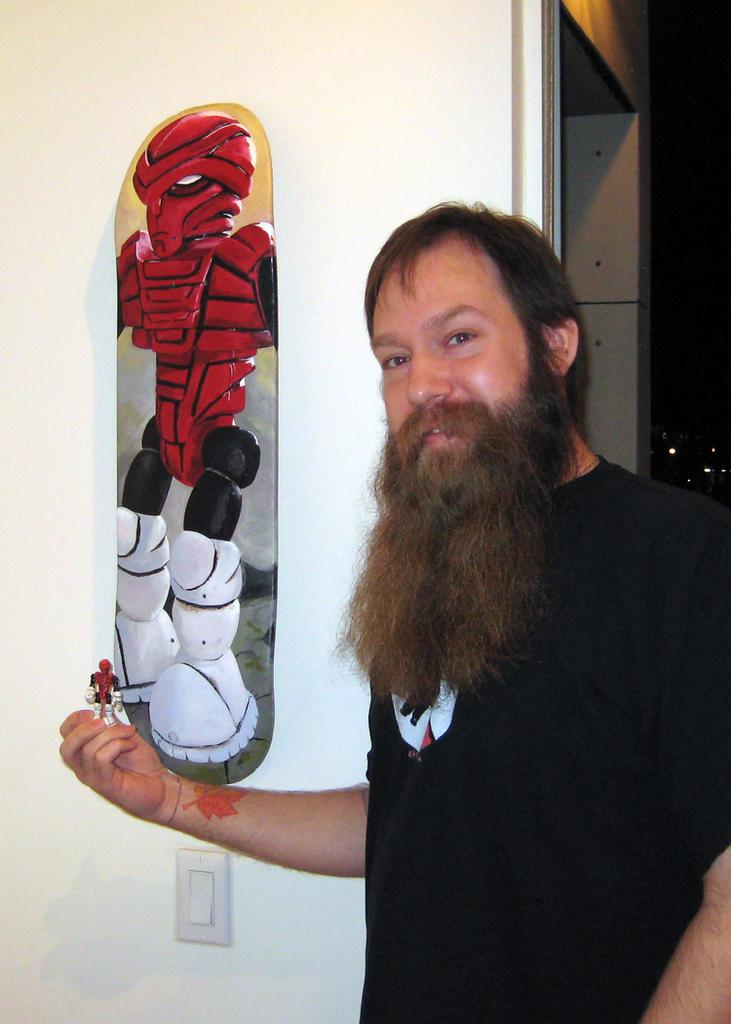What is the main subject in the image? There is a person standing in the image. What can be seen on the wall in the image? There is a board on the wall in the image, and it has a cartoon painting on painting on it. What type of painting is on the board? The painting on the board is a cartoon. What is the person holding in their hand? The person is holding a cartoon toy in their hand. What type of error can be seen in the person's throat in the image? There is no mention of any error or throat-related issue in the image. The person is holding a cartoon toy, and there is a cartoon painting on the board on the wall. 